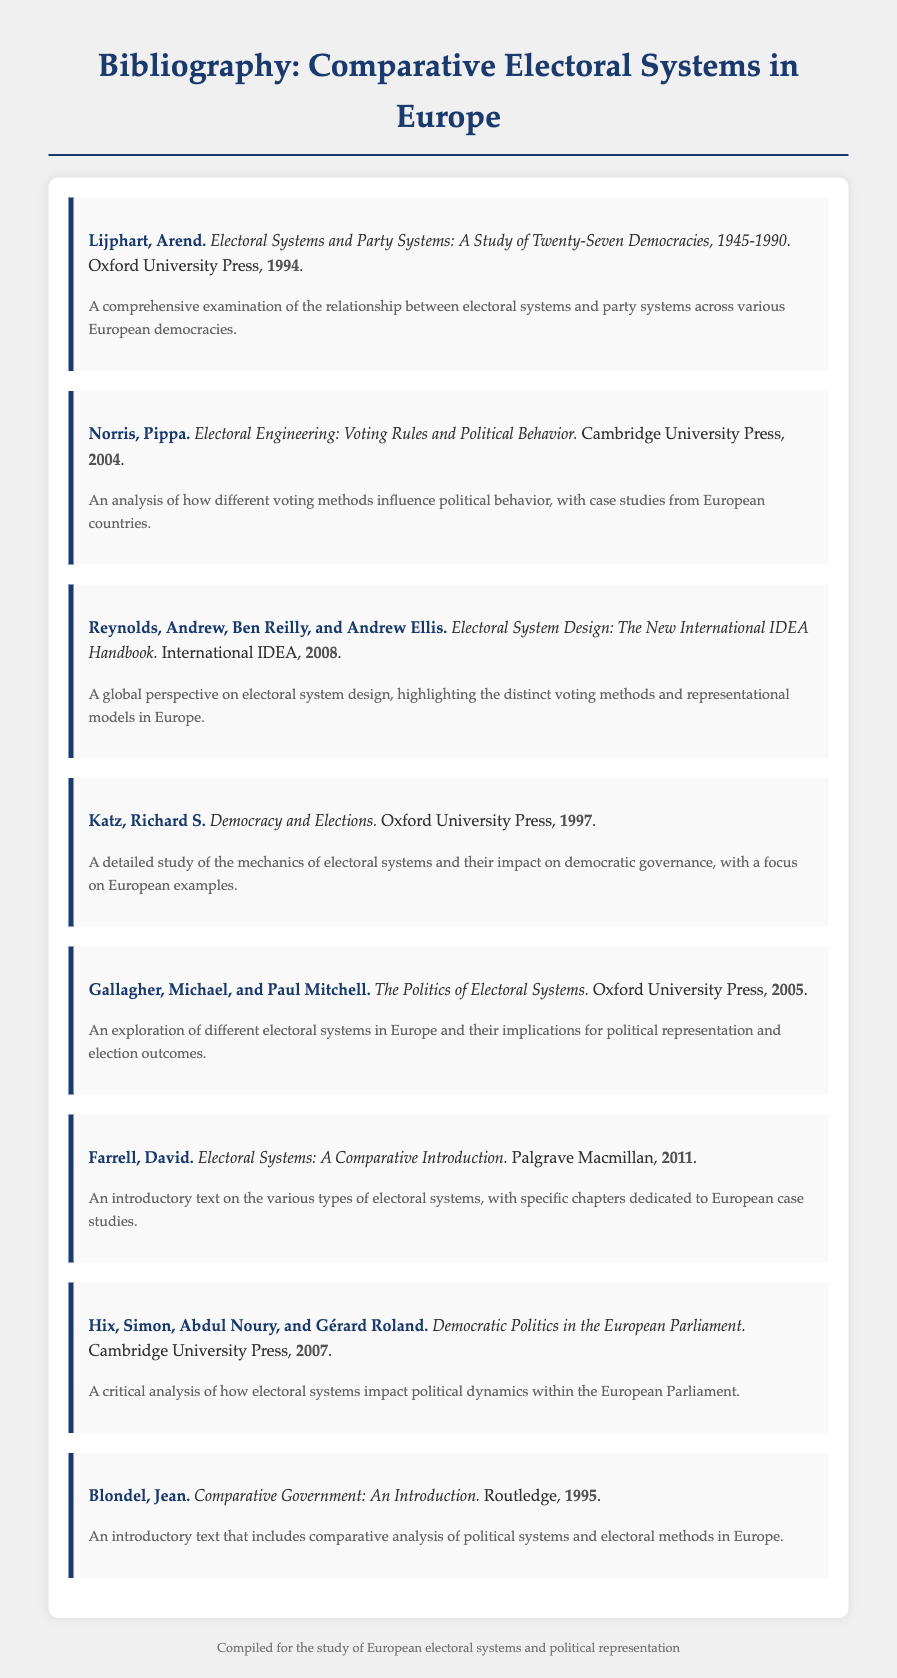what is the title of Arend Lijphart's work? The title is provided in the citation entry for Arend Lijphart's work, which is written in italics.
Answer: Electoral Systems and Party Systems: A Study of Twenty-Seven Democracies, 1945-1990 who authored the book on electoral engineering? The name can be found in the citation entry for the book, where the author is listed in bold.
Answer: Pippa Norris what year was the publication by Reynolds et al. released? The publication year is indicated next to the title in the citation entry for this work.
Answer: 2008 name one key theme discussed in Gallagher and Mitchell's book. The theme can be inferred from the description provided in the citation entry for this book.
Answer: Political representation who published "Democratic Politics in the European Parliament"? The publisher's name is specified in the citation entry for this work.
Answer: Cambridge University Press how many authors contributed to the work titled "Electoral Systems: A Comparative Introduction"? The total number of authors can be derived from the entry’s citation format; it lists the author clearly.
Answer: One 